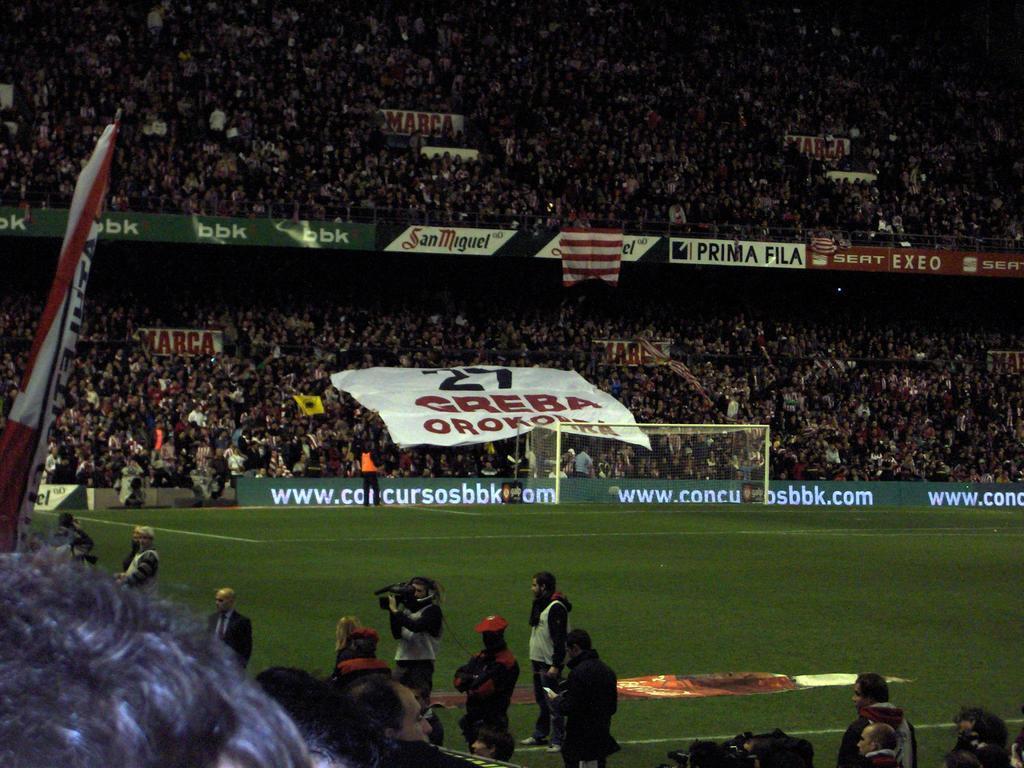In one or two sentences, can you explain what this image depicts? This picture is taken in a stadium. The stadium is filled with the people and the people are holding the banner with some text. At the bottom there are people. There is a person in the center and he is holding a camera. Beside him, there is another person in red clothes. Towards the left, there is a flag. In the center, there is a ground. 